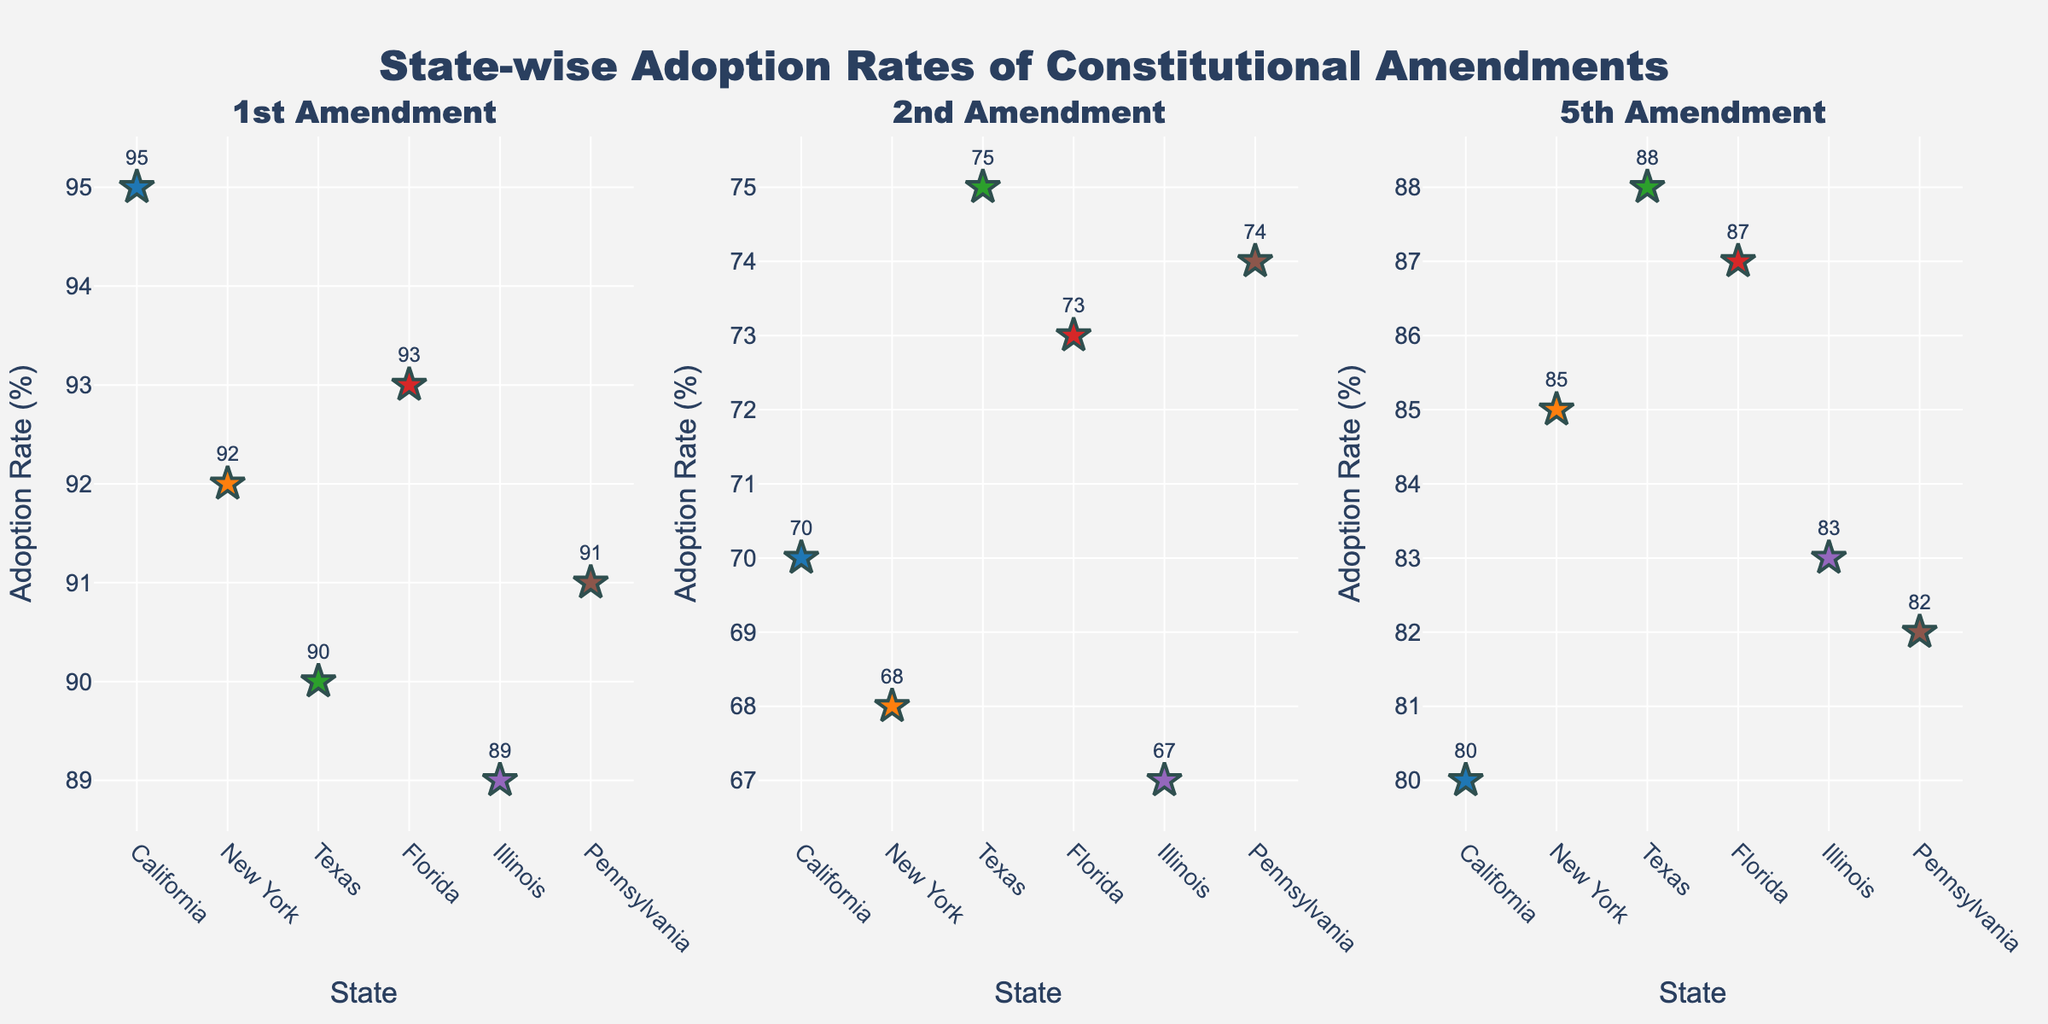What's the title of the figure? The title of the figure is displayed prominently at the top. It says "State-wise Adoption Rates of Constitutional Amendments" as per the code provided.
Answer: State-wise Adoption Rates of Constitutional Amendments Which state has the highest adoption rate for the 1st Amendment? From the 1st Amendment subplot, the highest adoption rate is marked next to Florida. The text near the marker shows 93.
Answer: Florida What is the average adoption rate for the 2nd Amendment across all the states? To find the average, sum the adoption rates for the 2nd Amendment (70 + 68 + 75 + 73 + 67 + 74) and divide by the number of states (6). The sum is 427, and the average is 427 divided by 6.
Answer: 71.17 Which state has the lowest adoption rate for the 5th Amendment? In the 5th Amendment subplot, the lowest marked adoption rate is next to Illinois, displaying a rate of 83.
Answer: Illinois Compare the adoption rates for the 1st and 2nd Amendments in New York. Which one is higher? From the figure, New York's adoption rate for the 1st Amendment is marked as 92, while for the 2nd Amendment, it is 68. Clearly, 92 is higher than 68.
Answer: 1st Amendment What is the total adoption rate of the 1st Amendment for California, Florida, and Pennsylvania combined? Sum the adoption rates for the 1st Amendment in California, Florida, and Pennsylvania (95 + 93 + 91). The sum is 279.
Answer: 279 Which Amendment has the most uniform adoption rates across states? To identify the most uniform adoption rates, visually compare the consistency of adoption rates in each subplot. The 2nd Amendment has rates closely clustered near 70-75 across all states, appearing most uniform.
Answer: 2nd Amendment How many subplots are shown in the figure? The code and the layout indicate 1 row and 3 columns, so there are 3 subplots in total.
Answer: 3 